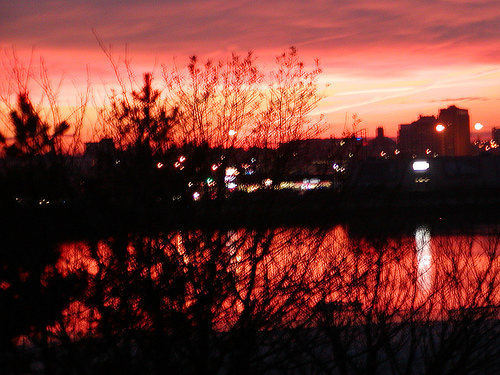<image>
Is there a sky behind the building? Yes. From this viewpoint, the sky is positioned behind the building, with the building partially or fully occluding the sky. Where is the building in relation to the sky? Is it in the sky? No. The building is not contained within the sky. These objects have a different spatial relationship. 